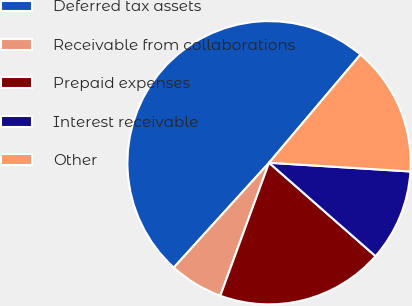Convert chart to OTSL. <chart><loc_0><loc_0><loc_500><loc_500><pie_chart><fcel>Deferred tax assets<fcel>Receivable from collaborations<fcel>Prepaid expenses<fcel>Interest receivable<fcel>Other<nl><fcel>49.43%<fcel>6.15%<fcel>19.13%<fcel>10.48%<fcel>14.81%<nl></chart> 